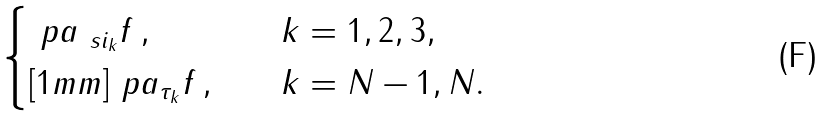<formula> <loc_0><loc_0><loc_500><loc_500>\begin{cases} \ p a _ { \ s i _ { k } } f \, , \quad & k = 1 , 2 , 3 , \\ [ 1 m m ] \ p a _ { \tau _ { k } } f \, , \quad & k = N - 1 , N . \end{cases}</formula> 